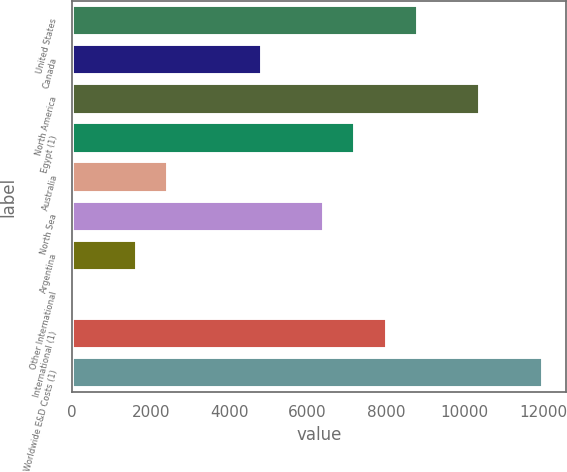Convert chart to OTSL. <chart><loc_0><loc_0><loc_500><loc_500><bar_chart><fcel>United States<fcel>Canada<fcel>North America<fcel>Egypt (1)<fcel>Australia<fcel>North Sea<fcel>Argentina<fcel>Other International<fcel>International (1)<fcel>Worldwide E&D Costs (1)<nl><fcel>8807.1<fcel>4831.6<fcel>10397.3<fcel>7216.9<fcel>2446.3<fcel>6421.8<fcel>1651.2<fcel>61<fcel>8012<fcel>11987.5<nl></chart> 